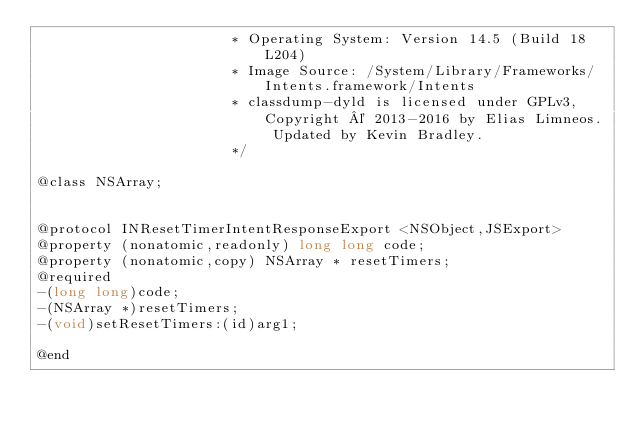<code> <loc_0><loc_0><loc_500><loc_500><_C_>                       * Operating System: Version 14.5 (Build 18L204)
                       * Image Source: /System/Library/Frameworks/Intents.framework/Intents
                       * classdump-dyld is licensed under GPLv3, Copyright © 2013-2016 by Elias Limneos. Updated by Kevin Bradley.
                       */

@class NSArray;


@protocol INResetTimerIntentResponseExport <NSObject,JSExport>
@property (nonatomic,readonly) long long code; 
@property (nonatomic,copy) NSArray * resetTimers; 
@required
-(long long)code;
-(NSArray *)resetTimers;
-(void)setResetTimers:(id)arg1;

@end

</code> 